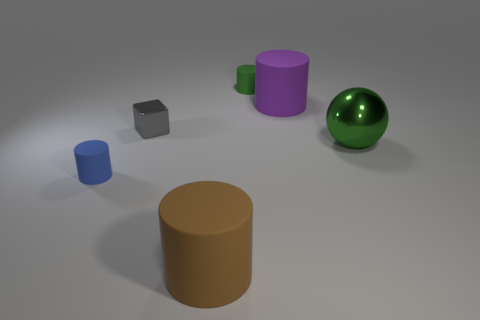Add 2 purple rubber things. How many objects exist? 8 Subtract all spheres. How many objects are left? 5 Add 2 tiny blue things. How many tiny blue things are left? 3 Add 3 gray metal objects. How many gray metal objects exist? 4 Subtract 1 brown cylinders. How many objects are left? 5 Subtract all cyan metallic blocks. Subtract all purple objects. How many objects are left? 5 